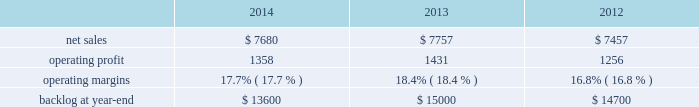Is&gs 2019 operating profit decreased $ 60 million , or 8% ( 8 % ) , for 2014 compared to 2013 .
The decrease was primarily attributable to the activities mentioned above for sales , lower risk retirements and reserves recorded on an international program , partially offset by severance recoveries related to the restructuring announced in november 2013 of approximately $ 20 million for 2014 .
Adjustments not related to volume , including net profit booking rate adjustments , were approximately $ 30 million lower for 2014 compared to 2013 .
2013 compared to 2012 is&gs 2019 net sales decreased $ 479 million , or 5% ( 5 % ) , for 2013 compared to 2012 .
The decrease was attributable to lower net sales of about $ 495 million due to decreased volume on various programs ( command and control programs for classified customers , ngi and eram programs ) ; and approximately $ 320 million due to the completion of certain programs ( such as total information processing support services , the transportation worker identification credential and the outsourcing desktop initiative for nasa ) .
The decrease was partially offset by higher net sales of about $ 340 million due to the start-up of certain programs ( such as the disa gsm-o and the national science foundation antarctic support ) .
Is&gs 2019 operating profit decreased $ 49 million , or 6% ( 6 % ) , for 2013 compared to 2012 .
The decrease was primarily attributable to lower operating profit of about $ 55 million due to certain programs nearing the end of their life cycles , partially offset by higher operating profit of approximately $ 15 million due to the start-up of certain programs .
Adjustments not related to volume , including net profit booking rate adjustments and other matters , were comparable for 2013 compared to 2012 .
Backlog backlog increased in 2014 compared to 2013 primarily due to several multi-year international awards and various u.s .
Multi-year extensions .
This increase was partially offset by declining activities on various direct warfighter support and command and control programs impacted by defense budget reductions .
Backlog decreased in 2013 compared to 2012 primarily due to lower orders on several programs ( such as eram and ngi ) , higher sales on certain programs ( the national science foundation antarctic support and the disa gsm-o ) and declining activities on several smaller programs primarily due to the continued downturn in federal information technology budgets .
Trends we expect is&gs 2019 net sales to decline in 2015 in the low to mid single digit percentage range as compared to 2014 , primarily driven by the continued downturn in federal information technology budgets , an increasingly competitive environment , including the disaggregation of existing contracts , and new contract award delays , partially offset by increased sales resulting from acquisitions that occurred during the year .
Operating profit is expected to decline in the low double digit percentage range in 2015 primarily driven by volume and an increase in intangible amortization from 2014 acquisition activity , resulting in 2015 margins that are lower than 2014 results .
Missiles and fire control our mfc business segment provides air and missile defense systems ; tactical missiles and air-to-ground precision strike weapon systems ; logistics and other technical services ; fire control systems ; mission operations support , readiness , engineering support and integration services ; and manned and unmanned ground vehicles .
Mfc 2019s major programs include pac-3 , thaad , multiple launch rocket system , hellfire , jassm , javelin , apache , sniper ae , low altitude navigation and targeting infrared for night ( lantirn ae ) and sof clss .
Mfc 2019s operating results included the following ( in millions ) : .
2014 compared to 2013 mfc 2019s net sales for 2014 decreased $ 77 million , or 1% ( 1 % ) , compared to 2013 .
The decrease was primarily attributable to lower net sales of approximately $ 385 million for technical services programs due to decreased volume reflecting market pressures ; and about $ 115 million for tactical missile programs due to fewer deliveries ( primarily high mobility artillery .
What is the growth rate in operating profit for mfc in 2013? 
Computations: ((1431 - 1256) / 1256)
Answer: 0.13933. 